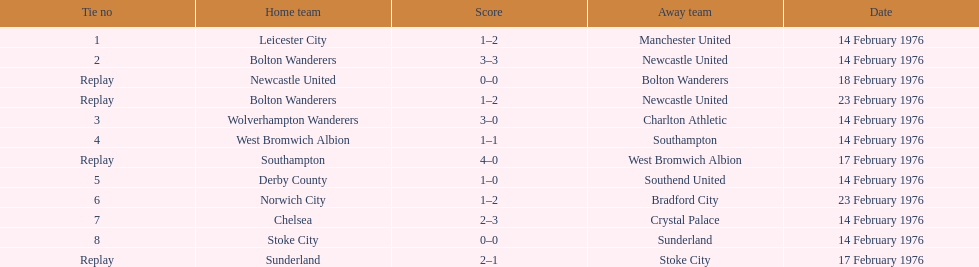Which groups played on the identical day as leicester city and manchester united? Bolton Wanderers, Newcastle United. 